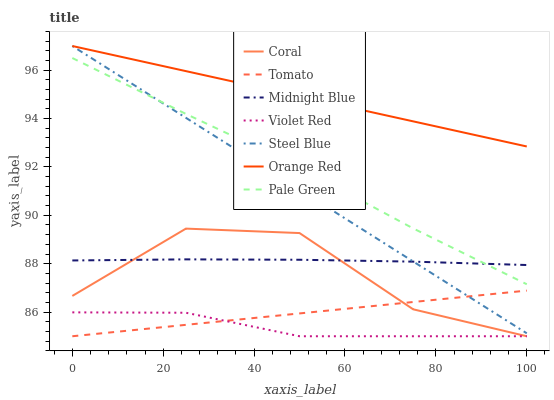Does Violet Red have the minimum area under the curve?
Answer yes or no. Yes. Does Orange Red have the maximum area under the curve?
Answer yes or no. Yes. Does Midnight Blue have the minimum area under the curve?
Answer yes or no. No. Does Midnight Blue have the maximum area under the curve?
Answer yes or no. No. Is Steel Blue the smoothest?
Answer yes or no. Yes. Is Coral the roughest?
Answer yes or no. Yes. Is Violet Red the smoothest?
Answer yes or no. No. Is Violet Red the roughest?
Answer yes or no. No. Does Tomato have the lowest value?
Answer yes or no. Yes. Does Midnight Blue have the lowest value?
Answer yes or no. No. Does Orange Red have the highest value?
Answer yes or no. Yes. Does Midnight Blue have the highest value?
Answer yes or no. No. Is Coral less than Orange Red?
Answer yes or no. Yes. Is Midnight Blue greater than Violet Red?
Answer yes or no. Yes. Does Tomato intersect Violet Red?
Answer yes or no. Yes. Is Tomato less than Violet Red?
Answer yes or no. No. Is Tomato greater than Violet Red?
Answer yes or no. No. Does Coral intersect Orange Red?
Answer yes or no. No. 